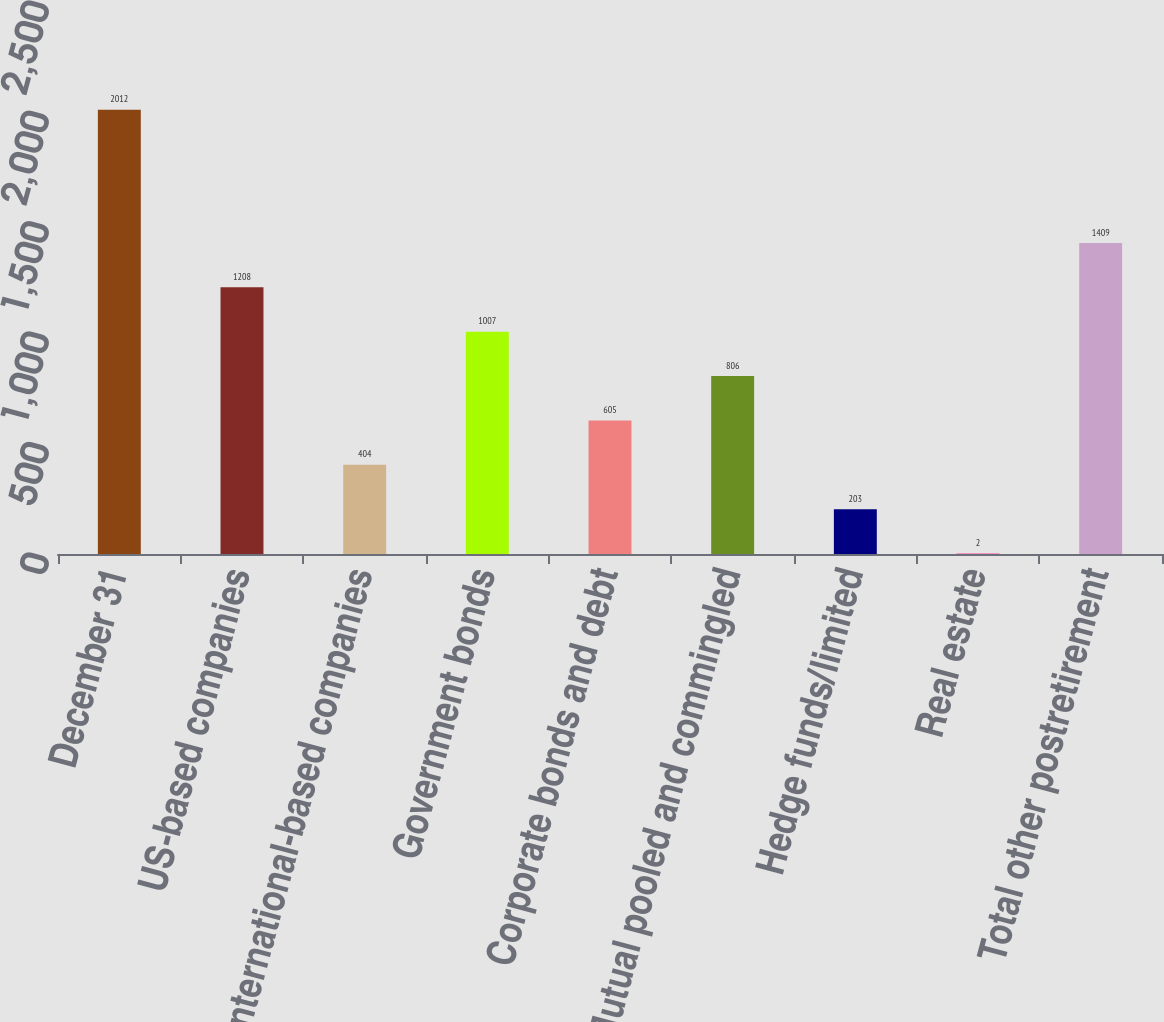<chart> <loc_0><loc_0><loc_500><loc_500><bar_chart><fcel>December 31<fcel>US-based companies<fcel>International-based companies<fcel>Government bonds<fcel>Corporate bonds and debt<fcel>Mutual pooled and commingled<fcel>Hedge funds/limited<fcel>Real estate<fcel>Total other postretirement<nl><fcel>2012<fcel>1208<fcel>404<fcel>1007<fcel>605<fcel>806<fcel>203<fcel>2<fcel>1409<nl></chart> 